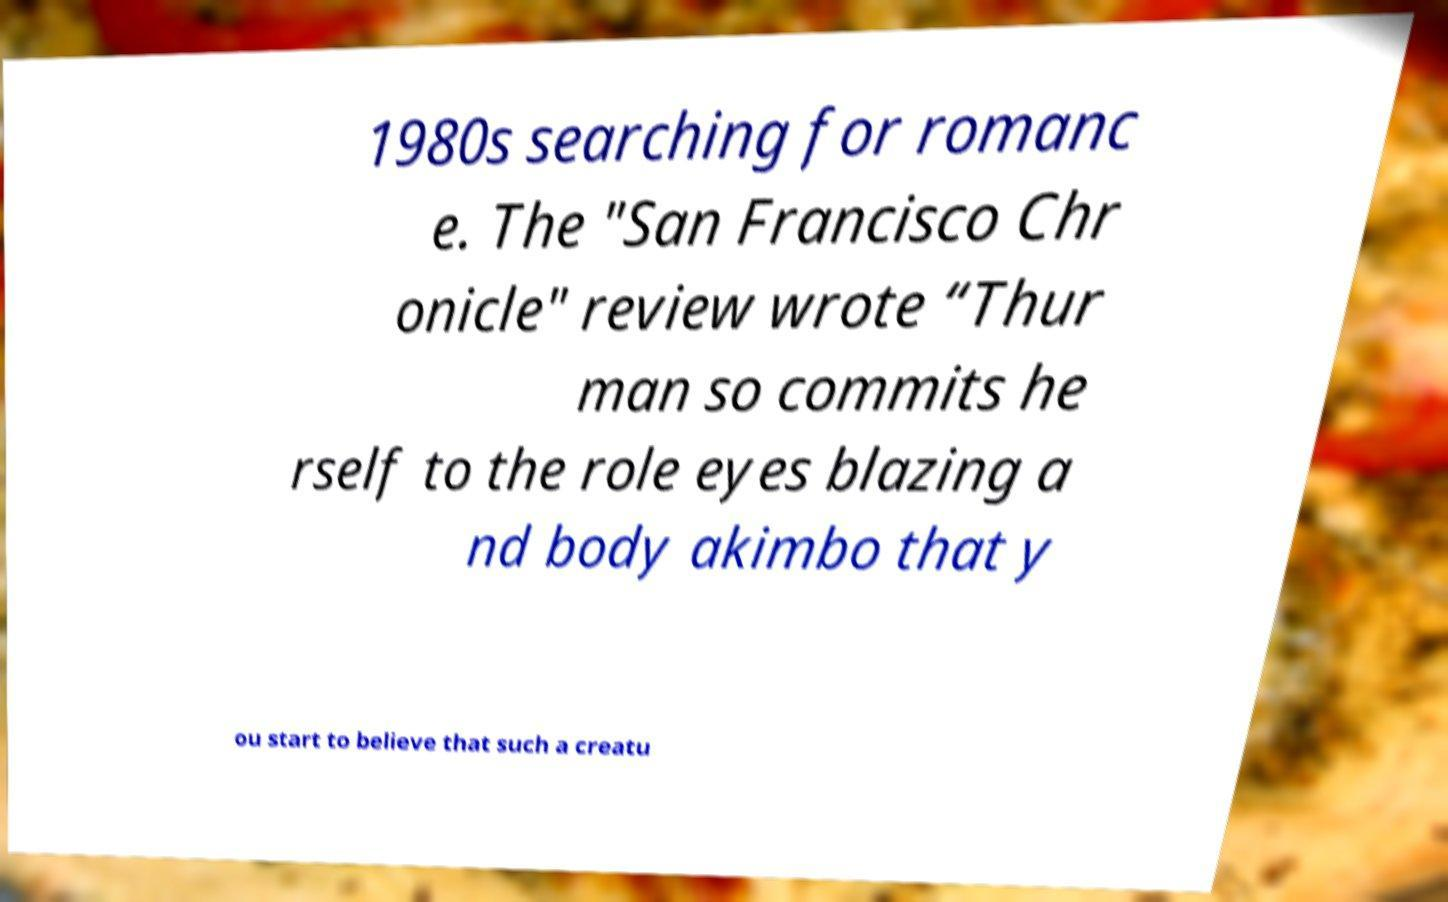Please read and relay the text visible in this image. What does it say? 1980s searching for romanc e. The "San Francisco Chr onicle" review wrote “Thur man so commits he rself to the role eyes blazing a nd body akimbo that y ou start to believe that such a creatu 